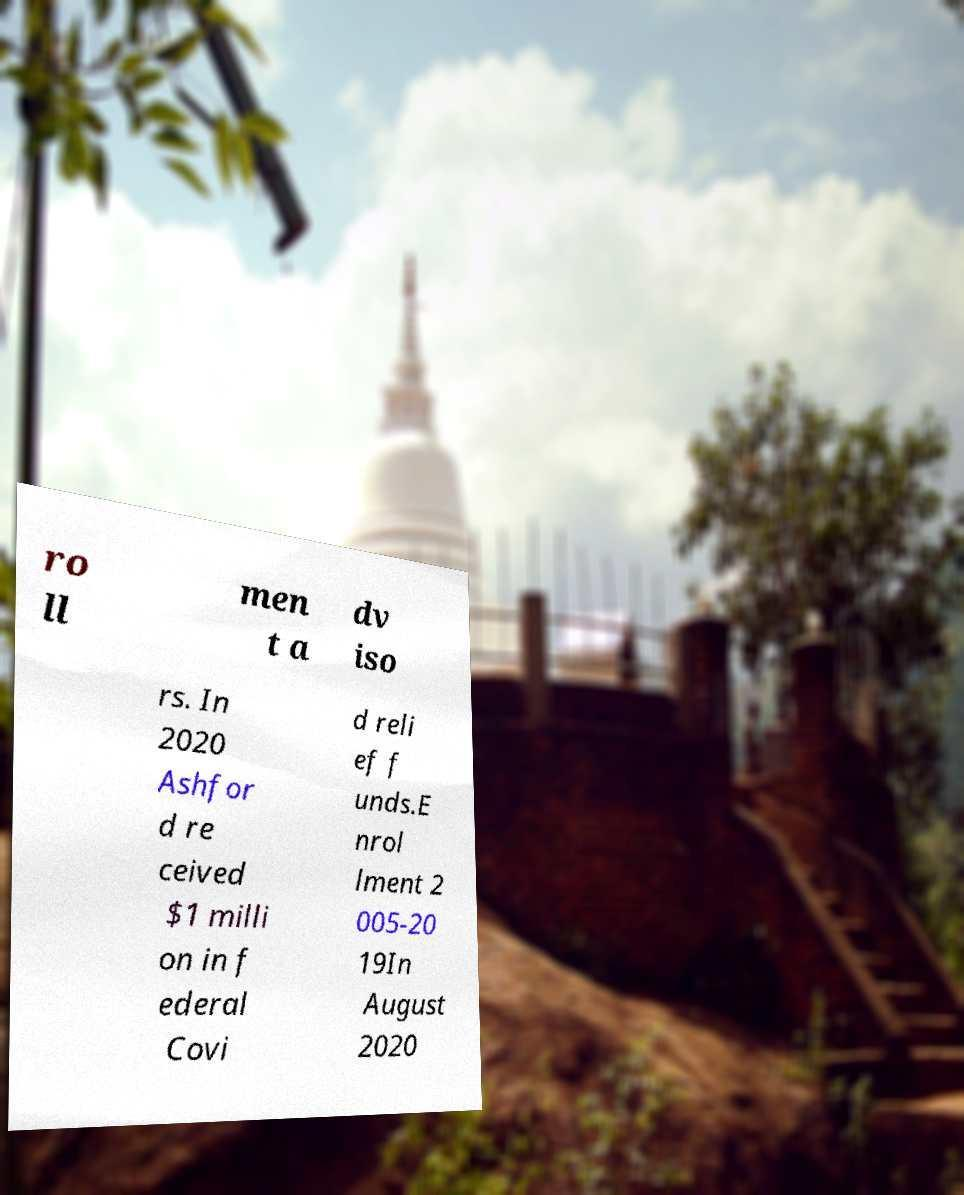Could you extract and type out the text from this image? ro ll men t a dv iso rs. In 2020 Ashfor d re ceived $1 milli on in f ederal Covi d reli ef f unds.E nrol lment 2 005-20 19In August 2020 